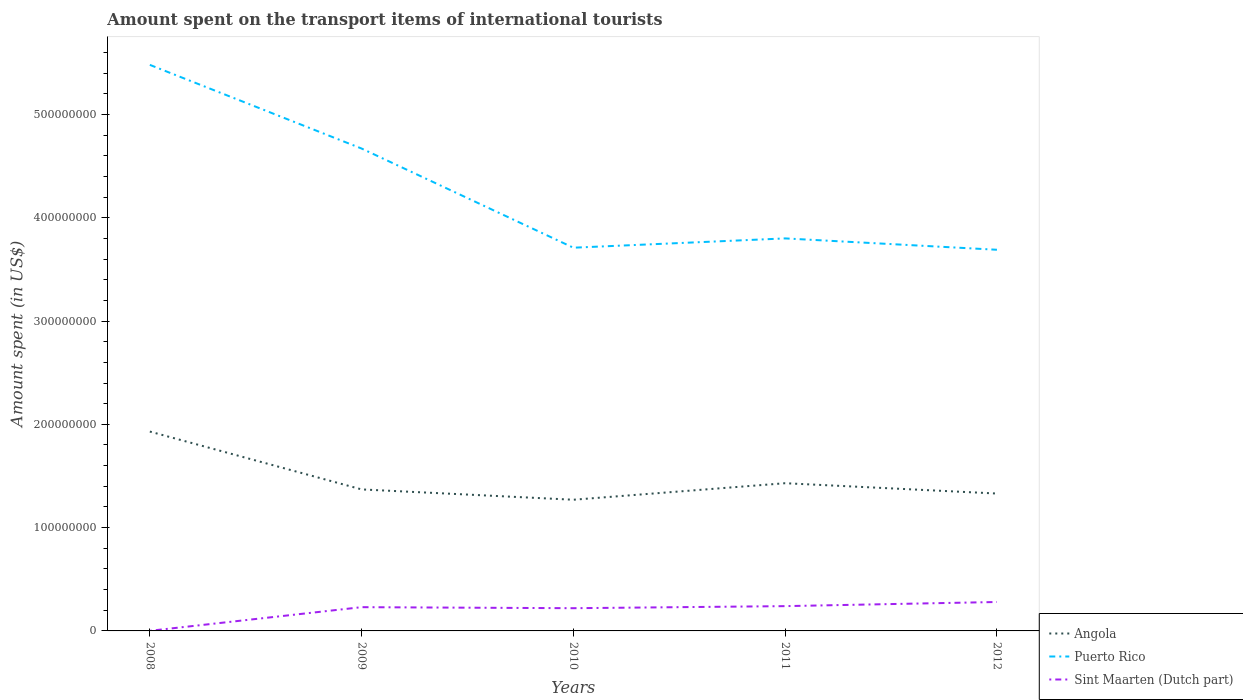How many different coloured lines are there?
Your answer should be compact. 3. Does the line corresponding to Angola intersect with the line corresponding to Puerto Rico?
Make the answer very short. No. Across all years, what is the maximum amount spent on the transport items of international tourists in Sint Maarten (Dutch part)?
Offer a terse response. 1.00e+05. In which year was the amount spent on the transport items of international tourists in Angola maximum?
Make the answer very short. 2010. What is the total amount spent on the transport items of international tourists in Angola in the graph?
Provide a succinct answer. 1.00e+07. What is the difference between the highest and the second highest amount spent on the transport items of international tourists in Puerto Rico?
Your answer should be very brief. 1.79e+08. What is the difference between the highest and the lowest amount spent on the transport items of international tourists in Sint Maarten (Dutch part)?
Offer a very short reply. 4. How many lines are there?
Keep it short and to the point. 3. What is the difference between two consecutive major ticks on the Y-axis?
Keep it short and to the point. 1.00e+08. Does the graph contain grids?
Ensure brevity in your answer.  No. Where does the legend appear in the graph?
Your answer should be compact. Bottom right. What is the title of the graph?
Ensure brevity in your answer.  Amount spent on the transport items of international tourists. What is the label or title of the Y-axis?
Offer a very short reply. Amount spent (in US$). What is the Amount spent (in US$) in Angola in 2008?
Ensure brevity in your answer.  1.93e+08. What is the Amount spent (in US$) of Puerto Rico in 2008?
Offer a very short reply. 5.48e+08. What is the Amount spent (in US$) of Sint Maarten (Dutch part) in 2008?
Provide a short and direct response. 1.00e+05. What is the Amount spent (in US$) of Angola in 2009?
Offer a very short reply. 1.37e+08. What is the Amount spent (in US$) of Puerto Rico in 2009?
Your answer should be compact. 4.67e+08. What is the Amount spent (in US$) in Sint Maarten (Dutch part) in 2009?
Make the answer very short. 2.30e+07. What is the Amount spent (in US$) of Angola in 2010?
Give a very brief answer. 1.27e+08. What is the Amount spent (in US$) of Puerto Rico in 2010?
Give a very brief answer. 3.71e+08. What is the Amount spent (in US$) of Sint Maarten (Dutch part) in 2010?
Your answer should be very brief. 2.20e+07. What is the Amount spent (in US$) of Angola in 2011?
Give a very brief answer. 1.43e+08. What is the Amount spent (in US$) in Puerto Rico in 2011?
Offer a very short reply. 3.80e+08. What is the Amount spent (in US$) in Sint Maarten (Dutch part) in 2011?
Give a very brief answer. 2.40e+07. What is the Amount spent (in US$) in Angola in 2012?
Ensure brevity in your answer.  1.33e+08. What is the Amount spent (in US$) in Puerto Rico in 2012?
Keep it short and to the point. 3.69e+08. What is the Amount spent (in US$) of Sint Maarten (Dutch part) in 2012?
Offer a terse response. 2.80e+07. Across all years, what is the maximum Amount spent (in US$) of Angola?
Keep it short and to the point. 1.93e+08. Across all years, what is the maximum Amount spent (in US$) in Puerto Rico?
Ensure brevity in your answer.  5.48e+08. Across all years, what is the maximum Amount spent (in US$) of Sint Maarten (Dutch part)?
Offer a very short reply. 2.80e+07. Across all years, what is the minimum Amount spent (in US$) of Angola?
Your answer should be compact. 1.27e+08. Across all years, what is the minimum Amount spent (in US$) of Puerto Rico?
Provide a short and direct response. 3.69e+08. Across all years, what is the minimum Amount spent (in US$) of Sint Maarten (Dutch part)?
Offer a very short reply. 1.00e+05. What is the total Amount spent (in US$) of Angola in the graph?
Offer a terse response. 7.33e+08. What is the total Amount spent (in US$) in Puerto Rico in the graph?
Keep it short and to the point. 2.14e+09. What is the total Amount spent (in US$) in Sint Maarten (Dutch part) in the graph?
Keep it short and to the point. 9.71e+07. What is the difference between the Amount spent (in US$) in Angola in 2008 and that in 2009?
Provide a succinct answer. 5.60e+07. What is the difference between the Amount spent (in US$) in Puerto Rico in 2008 and that in 2009?
Give a very brief answer. 8.10e+07. What is the difference between the Amount spent (in US$) in Sint Maarten (Dutch part) in 2008 and that in 2009?
Your response must be concise. -2.29e+07. What is the difference between the Amount spent (in US$) in Angola in 2008 and that in 2010?
Provide a succinct answer. 6.60e+07. What is the difference between the Amount spent (in US$) of Puerto Rico in 2008 and that in 2010?
Provide a succinct answer. 1.77e+08. What is the difference between the Amount spent (in US$) in Sint Maarten (Dutch part) in 2008 and that in 2010?
Your answer should be compact. -2.19e+07. What is the difference between the Amount spent (in US$) of Puerto Rico in 2008 and that in 2011?
Provide a succinct answer. 1.68e+08. What is the difference between the Amount spent (in US$) in Sint Maarten (Dutch part) in 2008 and that in 2011?
Provide a succinct answer. -2.39e+07. What is the difference between the Amount spent (in US$) in Angola in 2008 and that in 2012?
Your answer should be compact. 6.00e+07. What is the difference between the Amount spent (in US$) of Puerto Rico in 2008 and that in 2012?
Provide a short and direct response. 1.79e+08. What is the difference between the Amount spent (in US$) of Sint Maarten (Dutch part) in 2008 and that in 2012?
Provide a succinct answer. -2.79e+07. What is the difference between the Amount spent (in US$) of Angola in 2009 and that in 2010?
Make the answer very short. 1.00e+07. What is the difference between the Amount spent (in US$) in Puerto Rico in 2009 and that in 2010?
Your answer should be compact. 9.60e+07. What is the difference between the Amount spent (in US$) of Angola in 2009 and that in 2011?
Keep it short and to the point. -6.00e+06. What is the difference between the Amount spent (in US$) in Puerto Rico in 2009 and that in 2011?
Offer a very short reply. 8.70e+07. What is the difference between the Amount spent (in US$) of Sint Maarten (Dutch part) in 2009 and that in 2011?
Your answer should be very brief. -1.00e+06. What is the difference between the Amount spent (in US$) of Angola in 2009 and that in 2012?
Offer a very short reply. 4.00e+06. What is the difference between the Amount spent (in US$) of Puerto Rico in 2009 and that in 2012?
Offer a terse response. 9.80e+07. What is the difference between the Amount spent (in US$) of Sint Maarten (Dutch part) in 2009 and that in 2012?
Give a very brief answer. -5.00e+06. What is the difference between the Amount spent (in US$) in Angola in 2010 and that in 2011?
Keep it short and to the point. -1.60e+07. What is the difference between the Amount spent (in US$) of Puerto Rico in 2010 and that in 2011?
Your response must be concise. -9.00e+06. What is the difference between the Amount spent (in US$) in Sint Maarten (Dutch part) in 2010 and that in 2011?
Keep it short and to the point. -2.00e+06. What is the difference between the Amount spent (in US$) of Angola in 2010 and that in 2012?
Ensure brevity in your answer.  -6.00e+06. What is the difference between the Amount spent (in US$) in Sint Maarten (Dutch part) in 2010 and that in 2012?
Make the answer very short. -6.00e+06. What is the difference between the Amount spent (in US$) in Angola in 2011 and that in 2012?
Offer a very short reply. 1.00e+07. What is the difference between the Amount spent (in US$) of Puerto Rico in 2011 and that in 2012?
Provide a succinct answer. 1.10e+07. What is the difference between the Amount spent (in US$) of Sint Maarten (Dutch part) in 2011 and that in 2012?
Your answer should be very brief. -4.00e+06. What is the difference between the Amount spent (in US$) of Angola in 2008 and the Amount spent (in US$) of Puerto Rico in 2009?
Your answer should be compact. -2.74e+08. What is the difference between the Amount spent (in US$) in Angola in 2008 and the Amount spent (in US$) in Sint Maarten (Dutch part) in 2009?
Make the answer very short. 1.70e+08. What is the difference between the Amount spent (in US$) in Puerto Rico in 2008 and the Amount spent (in US$) in Sint Maarten (Dutch part) in 2009?
Provide a short and direct response. 5.25e+08. What is the difference between the Amount spent (in US$) of Angola in 2008 and the Amount spent (in US$) of Puerto Rico in 2010?
Your answer should be very brief. -1.78e+08. What is the difference between the Amount spent (in US$) of Angola in 2008 and the Amount spent (in US$) of Sint Maarten (Dutch part) in 2010?
Provide a short and direct response. 1.71e+08. What is the difference between the Amount spent (in US$) in Puerto Rico in 2008 and the Amount spent (in US$) in Sint Maarten (Dutch part) in 2010?
Your response must be concise. 5.26e+08. What is the difference between the Amount spent (in US$) of Angola in 2008 and the Amount spent (in US$) of Puerto Rico in 2011?
Offer a very short reply. -1.87e+08. What is the difference between the Amount spent (in US$) of Angola in 2008 and the Amount spent (in US$) of Sint Maarten (Dutch part) in 2011?
Provide a short and direct response. 1.69e+08. What is the difference between the Amount spent (in US$) in Puerto Rico in 2008 and the Amount spent (in US$) in Sint Maarten (Dutch part) in 2011?
Provide a short and direct response. 5.24e+08. What is the difference between the Amount spent (in US$) in Angola in 2008 and the Amount spent (in US$) in Puerto Rico in 2012?
Your answer should be very brief. -1.76e+08. What is the difference between the Amount spent (in US$) of Angola in 2008 and the Amount spent (in US$) of Sint Maarten (Dutch part) in 2012?
Make the answer very short. 1.65e+08. What is the difference between the Amount spent (in US$) in Puerto Rico in 2008 and the Amount spent (in US$) in Sint Maarten (Dutch part) in 2012?
Offer a very short reply. 5.20e+08. What is the difference between the Amount spent (in US$) in Angola in 2009 and the Amount spent (in US$) in Puerto Rico in 2010?
Keep it short and to the point. -2.34e+08. What is the difference between the Amount spent (in US$) in Angola in 2009 and the Amount spent (in US$) in Sint Maarten (Dutch part) in 2010?
Make the answer very short. 1.15e+08. What is the difference between the Amount spent (in US$) of Puerto Rico in 2009 and the Amount spent (in US$) of Sint Maarten (Dutch part) in 2010?
Your answer should be very brief. 4.45e+08. What is the difference between the Amount spent (in US$) of Angola in 2009 and the Amount spent (in US$) of Puerto Rico in 2011?
Provide a succinct answer. -2.43e+08. What is the difference between the Amount spent (in US$) of Angola in 2009 and the Amount spent (in US$) of Sint Maarten (Dutch part) in 2011?
Make the answer very short. 1.13e+08. What is the difference between the Amount spent (in US$) in Puerto Rico in 2009 and the Amount spent (in US$) in Sint Maarten (Dutch part) in 2011?
Ensure brevity in your answer.  4.43e+08. What is the difference between the Amount spent (in US$) in Angola in 2009 and the Amount spent (in US$) in Puerto Rico in 2012?
Keep it short and to the point. -2.32e+08. What is the difference between the Amount spent (in US$) of Angola in 2009 and the Amount spent (in US$) of Sint Maarten (Dutch part) in 2012?
Your answer should be compact. 1.09e+08. What is the difference between the Amount spent (in US$) of Puerto Rico in 2009 and the Amount spent (in US$) of Sint Maarten (Dutch part) in 2012?
Your answer should be compact. 4.39e+08. What is the difference between the Amount spent (in US$) in Angola in 2010 and the Amount spent (in US$) in Puerto Rico in 2011?
Keep it short and to the point. -2.53e+08. What is the difference between the Amount spent (in US$) of Angola in 2010 and the Amount spent (in US$) of Sint Maarten (Dutch part) in 2011?
Provide a succinct answer. 1.03e+08. What is the difference between the Amount spent (in US$) in Puerto Rico in 2010 and the Amount spent (in US$) in Sint Maarten (Dutch part) in 2011?
Offer a very short reply. 3.47e+08. What is the difference between the Amount spent (in US$) of Angola in 2010 and the Amount spent (in US$) of Puerto Rico in 2012?
Ensure brevity in your answer.  -2.42e+08. What is the difference between the Amount spent (in US$) in Angola in 2010 and the Amount spent (in US$) in Sint Maarten (Dutch part) in 2012?
Provide a short and direct response. 9.90e+07. What is the difference between the Amount spent (in US$) in Puerto Rico in 2010 and the Amount spent (in US$) in Sint Maarten (Dutch part) in 2012?
Ensure brevity in your answer.  3.43e+08. What is the difference between the Amount spent (in US$) in Angola in 2011 and the Amount spent (in US$) in Puerto Rico in 2012?
Your response must be concise. -2.26e+08. What is the difference between the Amount spent (in US$) of Angola in 2011 and the Amount spent (in US$) of Sint Maarten (Dutch part) in 2012?
Offer a terse response. 1.15e+08. What is the difference between the Amount spent (in US$) of Puerto Rico in 2011 and the Amount spent (in US$) of Sint Maarten (Dutch part) in 2012?
Offer a terse response. 3.52e+08. What is the average Amount spent (in US$) of Angola per year?
Keep it short and to the point. 1.47e+08. What is the average Amount spent (in US$) in Puerto Rico per year?
Keep it short and to the point. 4.27e+08. What is the average Amount spent (in US$) of Sint Maarten (Dutch part) per year?
Offer a very short reply. 1.94e+07. In the year 2008, what is the difference between the Amount spent (in US$) of Angola and Amount spent (in US$) of Puerto Rico?
Make the answer very short. -3.55e+08. In the year 2008, what is the difference between the Amount spent (in US$) in Angola and Amount spent (in US$) in Sint Maarten (Dutch part)?
Keep it short and to the point. 1.93e+08. In the year 2008, what is the difference between the Amount spent (in US$) in Puerto Rico and Amount spent (in US$) in Sint Maarten (Dutch part)?
Keep it short and to the point. 5.48e+08. In the year 2009, what is the difference between the Amount spent (in US$) of Angola and Amount spent (in US$) of Puerto Rico?
Make the answer very short. -3.30e+08. In the year 2009, what is the difference between the Amount spent (in US$) in Angola and Amount spent (in US$) in Sint Maarten (Dutch part)?
Make the answer very short. 1.14e+08. In the year 2009, what is the difference between the Amount spent (in US$) in Puerto Rico and Amount spent (in US$) in Sint Maarten (Dutch part)?
Ensure brevity in your answer.  4.44e+08. In the year 2010, what is the difference between the Amount spent (in US$) of Angola and Amount spent (in US$) of Puerto Rico?
Your answer should be compact. -2.44e+08. In the year 2010, what is the difference between the Amount spent (in US$) in Angola and Amount spent (in US$) in Sint Maarten (Dutch part)?
Provide a short and direct response. 1.05e+08. In the year 2010, what is the difference between the Amount spent (in US$) in Puerto Rico and Amount spent (in US$) in Sint Maarten (Dutch part)?
Provide a succinct answer. 3.49e+08. In the year 2011, what is the difference between the Amount spent (in US$) of Angola and Amount spent (in US$) of Puerto Rico?
Your response must be concise. -2.37e+08. In the year 2011, what is the difference between the Amount spent (in US$) of Angola and Amount spent (in US$) of Sint Maarten (Dutch part)?
Your answer should be compact. 1.19e+08. In the year 2011, what is the difference between the Amount spent (in US$) in Puerto Rico and Amount spent (in US$) in Sint Maarten (Dutch part)?
Make the answer very short. 3.56e+08. In the year 2012, what is the difference between the Amount spent (in US$) of Angola and Amount spent (in US$) of Puerto Rico?
Your answer should be compact. -2.36e+08. In the year 2012, what is the difference between the Amount spent (in US$) of Angola and Amount spent (in US$) of Sint Maarten (Dutch part)?
Ensure brevity in your answer.  1.05e+08. In the year 2012, what is the difference between the Amount spent (in US$) in Puerto Rico and Amount spent (in US$) in Sint Maarten (Dutch part)?
Offer a terse response. 3.41e+08. What is the ratio of the Amount spent (in US$) in Angola in 2008 to that in 2009?
Your answer should be very brief. 1.41. What is the ratio of the Amount spent (in US$) in Puerto Rico in 2008 to that in 2009?
Keep it short and to the point. 1.17. What is the ratio of the Amount spent (in US$) in Sint Maarten (Dutch part) in 2008 to that in 2009?
Your answer should be very brief. 0. What is the ratio of the Amount spent (in US$) of Angola in 2008 to that in 2010?
Your answer should be compact. 1.52. What is the ratio of the Amount spent (in US$) of Puerto Rico in 2008 to that in 2010?
Provide a succinct answer. 1.48. What is the ratio of the Amount spent (in US$) in Sint Maarten (Dutch part) in 2008 to that in 2010?
Offer a very short reply. 0. What is the ratio of the Amount spent (in US$) of Angola in 2008 to that in 2011?
Provide a succinct answer. 1.35. What is the ratio of the Amount spent (in US$) of Puerto Rico in 2008 to that in 2011?
Ensure brevity in your answer.  1.44. What is the ratio of the Amount spent (in US$) in Sint Maarten (Dutch part) in 2008 to that in 2011?
Keep it short and to the point. 0. What is the ratio of the Amount spent (in US$) of Angola in 2008 to that in 2012?
Make the answer very short. 1.45. What is the ratio of the Amount spent (in US$) of Puerto Rico in 2008 to that in 2012?
Your answer should be very brief. 1.49. What is the ratio of the Amount spent (in US$) of Sint Maarten (Dutch part) in 2008 to that in 2012?
Your response must be concise. 0. What is the ratio of the Amount spent (in US$) in Angola in 2009 to that in 2010?
Offer a terse response. 1.08. What is the ratio of the Amount spent (in US$) of Puerto Rico in 2009 to that in 2010?
Your answer should be very brief. 1.26. What is the ratio of the Amount spent (in US$) of Sint Maarten (Dutch part) in 2009 to that in 2010?
Your answer should be very brief. 1.05. What is the ratio of the Amount spent (in US$) in Angola in 2009 to that in 2011?
Keep it short and to the point. 0.96. What is the ratio of the Amount spent (in US$) of Puerto Rico in 2009 to that in 2011?
Offer a terse response. 1.23. What is the ratio of the Amount spent (in US$) in Angola in 2009 to that in 2012?
Provide a short and direct response. 1.03. What is the ratio of the Amount spent (in US$) in Puerto Rico in 2009 to that in 2012?
Give a very brief answer. 1.27. What is the ratio of the Amount spent (in US$) of Sint Maarten (Dutch part) in 2009 to that in 2012?
Keep it short and to the point. 0.82. What is the ratio of the Amount spent (in US$) of Angola in 2010 to that in 2011?
Provide a short and direct response. 0.89. What is the ratio of the Amount spent (in US$) of Puerto Rico in 2010 to that in 2011?
Your answer should be compact. 0.98. What is the ratio of the Amount spent (in US$) in Angola in 2010 to that in 2012?
Offer a terse response. 0.95. What is the ratio of the Amount spent (in US$) of Puerto Rico in 2010 to that in 2012?
Offer a very short reply. 1.01. What is the ratio of the Amount spent (in US$) in Sint Maarten (Dutch part) in 2010 to that in 2012?
Provide a short and direct response. 0.79. What is the ratio of the Amount spent (in US$) in Angola in 2011 to that in 2012?
Offer a very short reply. 1.08. What is the ratio of the Amount spent (in US$) of Puerto Rico in 2011 to that in 2012?
Ensure brevity in your answer.  1.03. What is the difference between the highest and the second highest Amount spent (in US$) in Puerto Rico?
Provide a short and direct response. 8.10e+07. What is the difference between the highest and the second highest Amount spent (in US$) of Sint Maarten (Dutch part)?
Offer a very short reply. 4.00e+06. What is the difference between the highest and the lowest Amount spent (in US$) in Angola?
Provide a succinct answer. 6.60e+07. What is the difference between the highest and the lowest Amount spent (in US$) in Puerto Rico?
Keep it short and to the point. 1.79e+08. What is the difference between the highest and the lowest Amount spent (in US$) of Sint Maarten (Dutch part)?
Provide a succinct answer. 2.79e+07. 